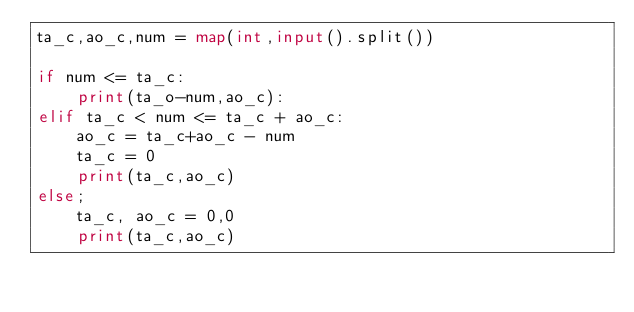Convert code to text. <code><loc_0><loc_0><loc_500><loc_500><_Python_>ta_c,ao_c,num = map(int,input().split())

if num <= ta_c:
    print(ta_o-num,ao_c):
elif ta_c < num <= ta_c + ao_c:
    ao_c = ta_c+ao_c - num
    ta_c = 0
    print(ta_c,ao_c)
else;
    ta_c, ao_c = 0,0
    print(ta_c,ao_c)</code> 